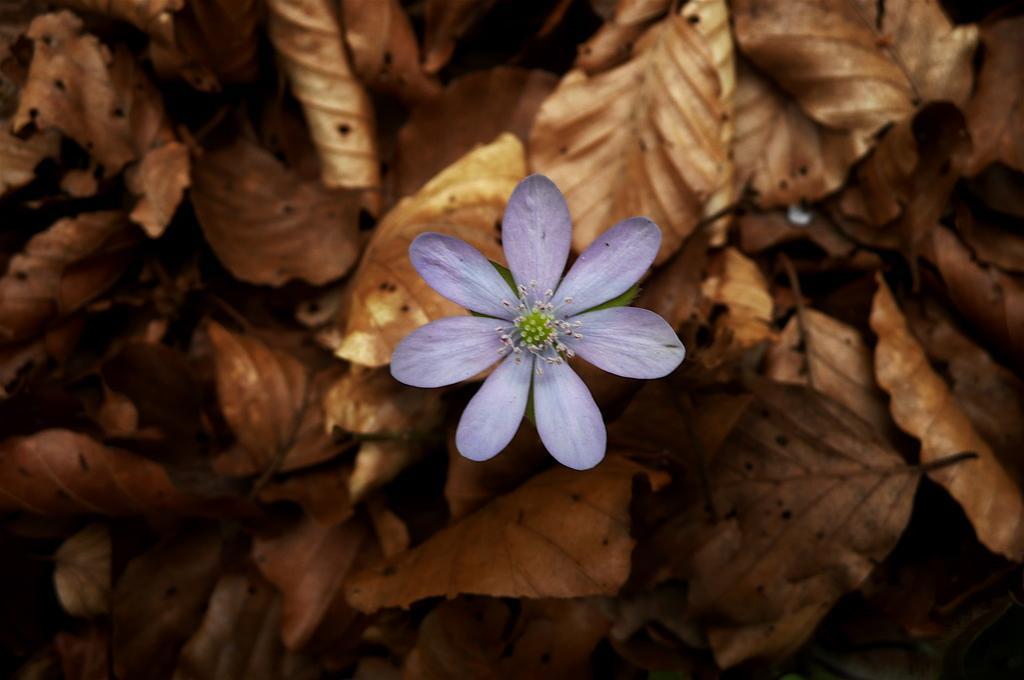In one or two sentences, can you explain what this image depicts? Here we can see a flower. Background there are dried leaves. 